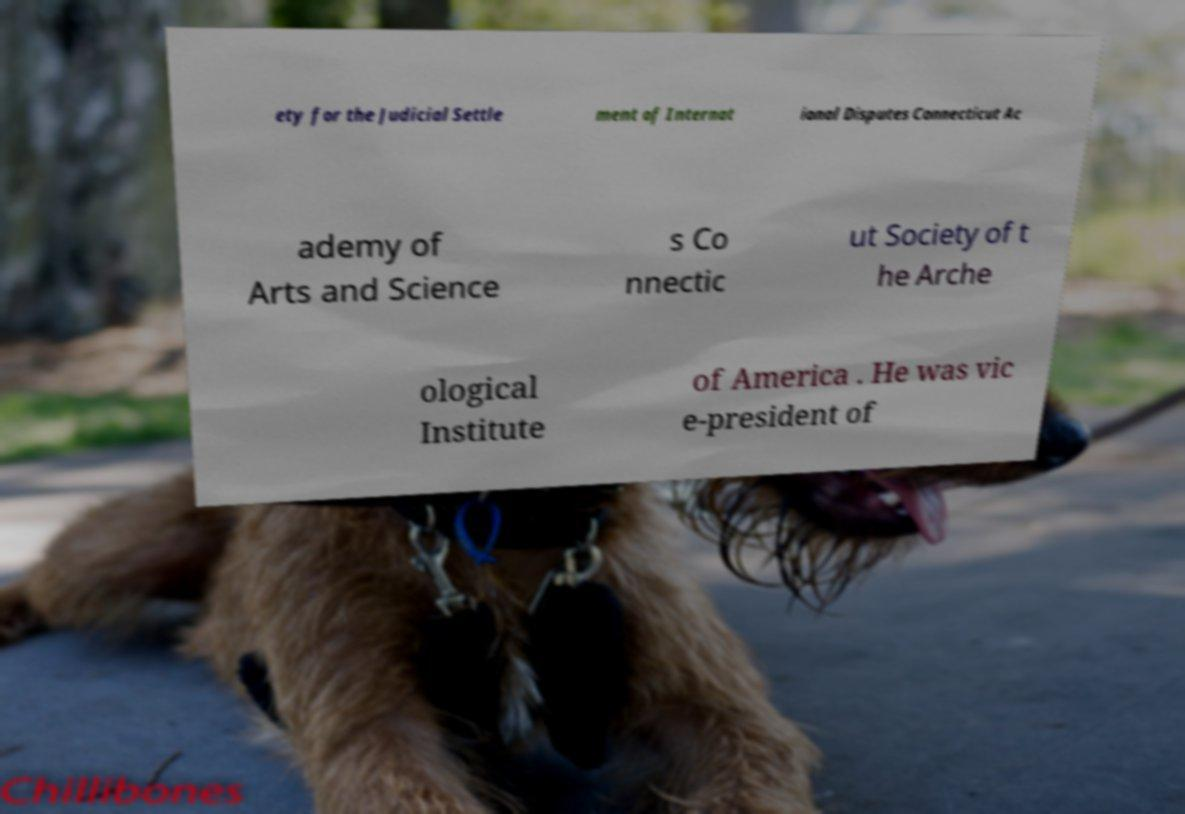What messages or text are displayed in this image? I need them in a readable, typed format. ety for the Judicial Settle ment of Internat ional Disputes Connecticut Ac ademy of Arts and Science s Co nnectic ut Society of t he Arche ological Institute of America . He was vic e-president of 